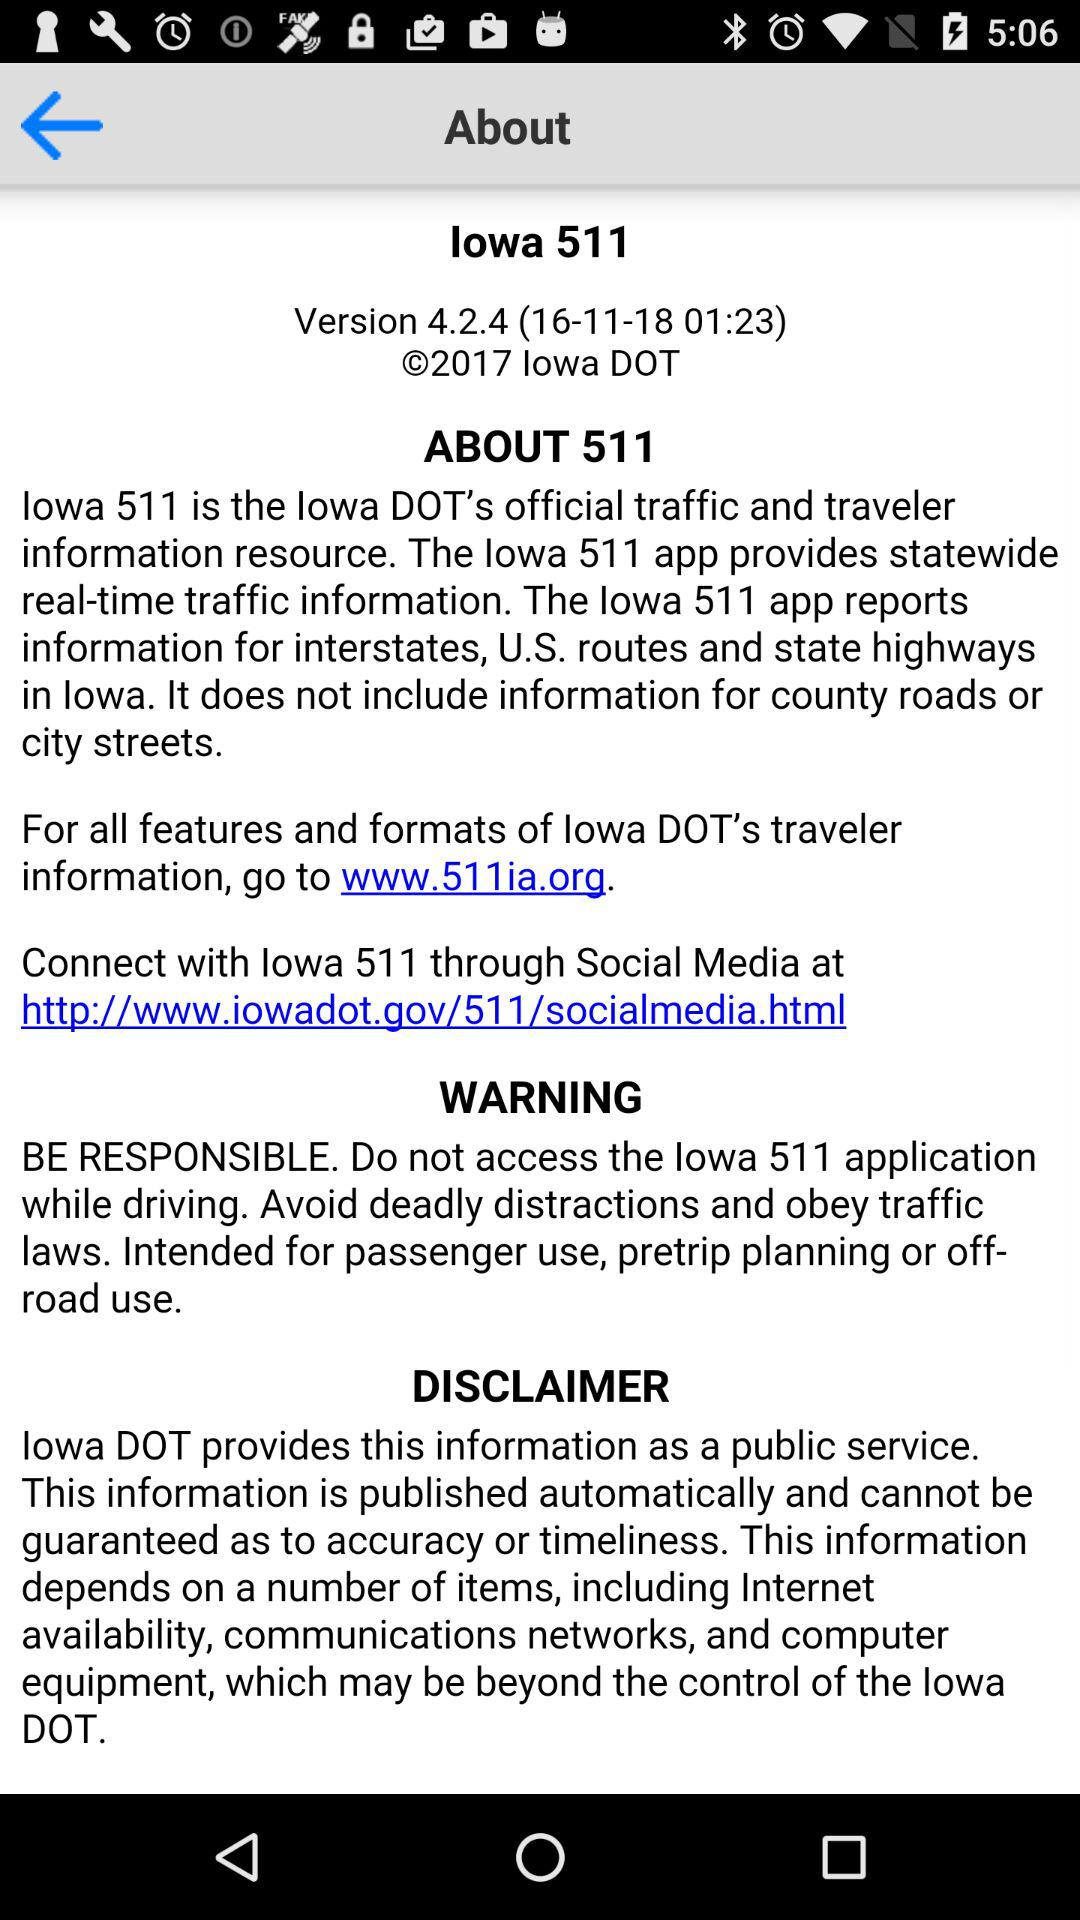What is the version of "lowa 511"? The version is 4.2.4. 